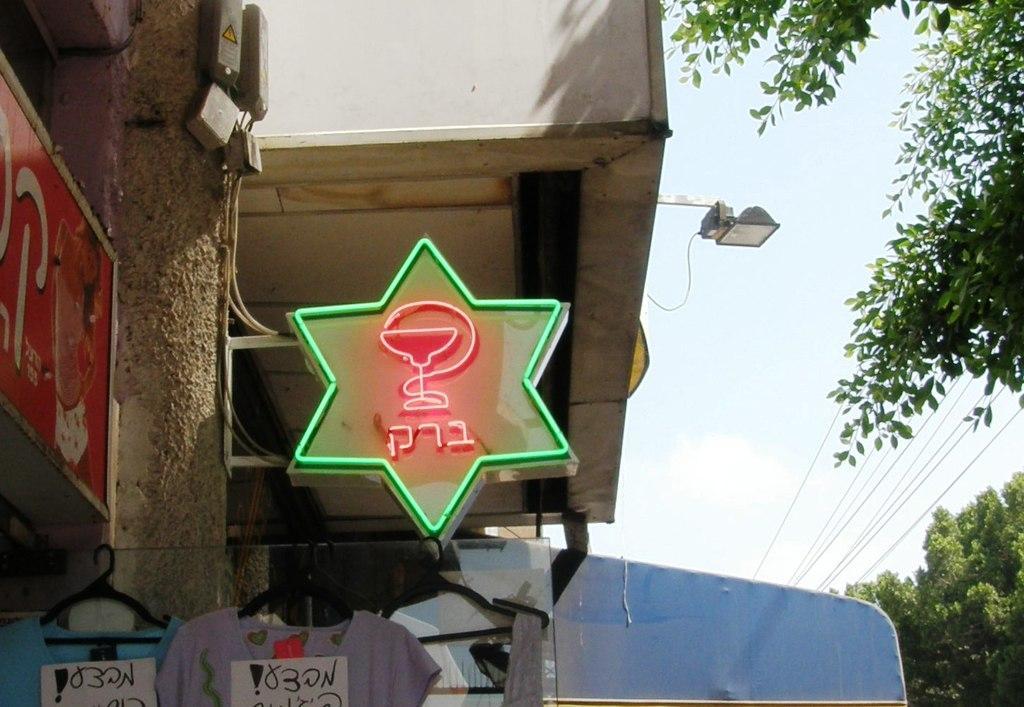How would you summarize this image in a sentence or two? In this image I can see a building which is cream in color, few boards which are green and red in color and to the pillar I can see few objects which are grey in color. I can see few clothes are hanged with hangers to the rope. In the background I can see the sky, few trees which are green in color, few wires and the light. 